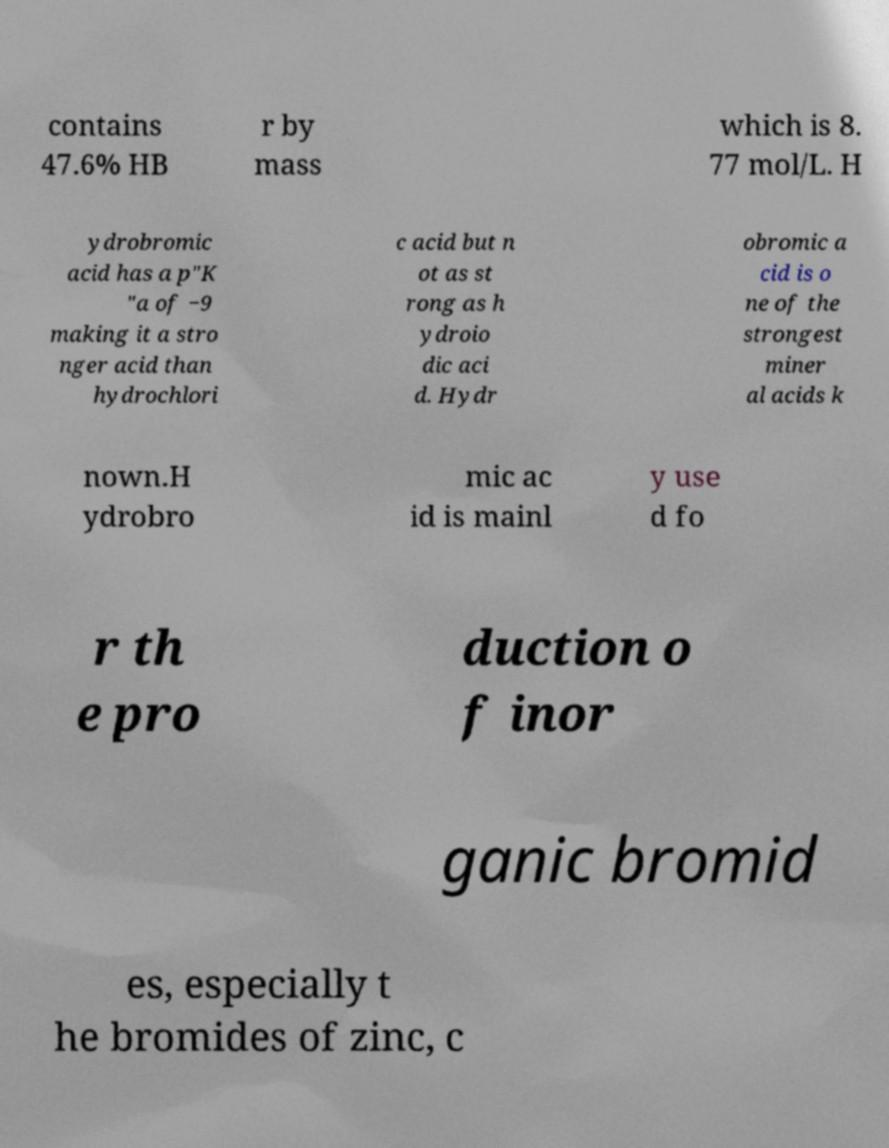I need the written content from this picture converted into text. Can you do that? contains 47.6% HB r by mass which is 8. 77 mol/L. H ydrobromic acid has a p"K "a of −9 making it a stro nger acid than hydrochlori c acid but n ot as st rong as h ydroio dic aci d. Hydr obromic a cid is o ne of the strongest miner al acids k nown.H ydrobro mic ac id is mainl y use d fo r th e pro duction o f inor ganic bromid es, especially t he bromides of zinc, c 